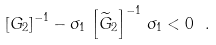Convert formula to latex. <formula><loc_0><loc_0><loc_500><loc_500>\left [ { G } _ { 2 } \right ] ^ { - 1 } - \sigma _ { 1 } \, \left [ \widetilde { G } _ { 2 } \right ] ^ { - 1 } \, \sigma _ { 1 } < 0 \ .</formula> 